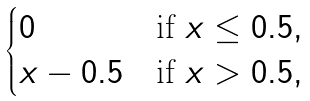Convert formula to latex. <formula><loc_0><loc_0><loc_500><loc_500>\begin{cases} 0 & \text {if } x \leq 0 . 5 , \\ x - 0 . 5 & \text {if } x > 0 . 5 , \end{cases}</formula> 